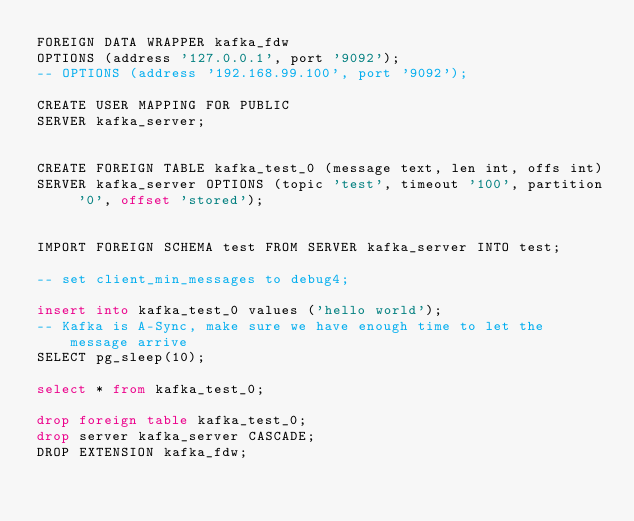<code> <loc_0><loc_0><loc_500><loc_500><_SQL_>FOREIGN DATA WRAPPER kafka_fdw
OPTIONS (address '127.0.0.1', port '9092');
-- OPTIONS (address '192.168.99.100', port '9092');

CREATE USER MAPPING FOR PUBLIC
SERVER kafka_server;


CREATE FOREIGN TABLE kafka_test_0 (message text, len int, offs int)
SERVER kafka_server OPTIONS (topic 'test', timeout '100', partition '0', offset 'stored');


IMPORT FOREIGN SCHEMA test FROM SERVER kafka_server INTO test;

-- set client_min_messages to debug4;

insert into kafka_test_0 values ('hello world');
-- Kafka is A-Sync, make sure we have enough time to let the message arrive
SELECT pg_sleep(10);

select * from kafka_test_0;

drop foreign table kafka_test_0;
drop server kafka_server CASCADE;
DROP EXTENSION kafka_fdw;
</code> 